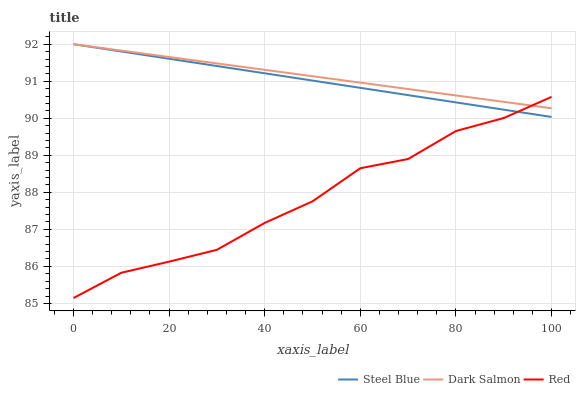Does Dark Salmon have the minimum area under the curve?
Answer yes or no. No. Does Red have the maximum area under the curve?
Answer yes or no. No. Is Dark Salmon the smoothest?
Answer yes or no. No. Is Dark Salmon the roughest?
Answer yes or no. No. Does Dark Salmon have the lowest value?
Answer yes or no. No. Does Red have the highest value?
Answer yes or no. No. 